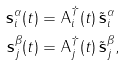Convert formula to latex. <formula><loc_0><loc_0><loc_500><loc_500>\mathbf s _ { i } ^ { \alpha } ( t ) & = \mathsf A ^ { \dagger } _ { i } ( t ) \, \tilde { \mathbf s } _ { i } ^ { \alpha } \\ \mathbf s _ { j } ^ { \beta } ( t ) & = \mathsf A ^ { \dagger } _ { j } ( t ) \, \tilde { \mathbf s } _ { j } ^ { \beta } ,</formula> 